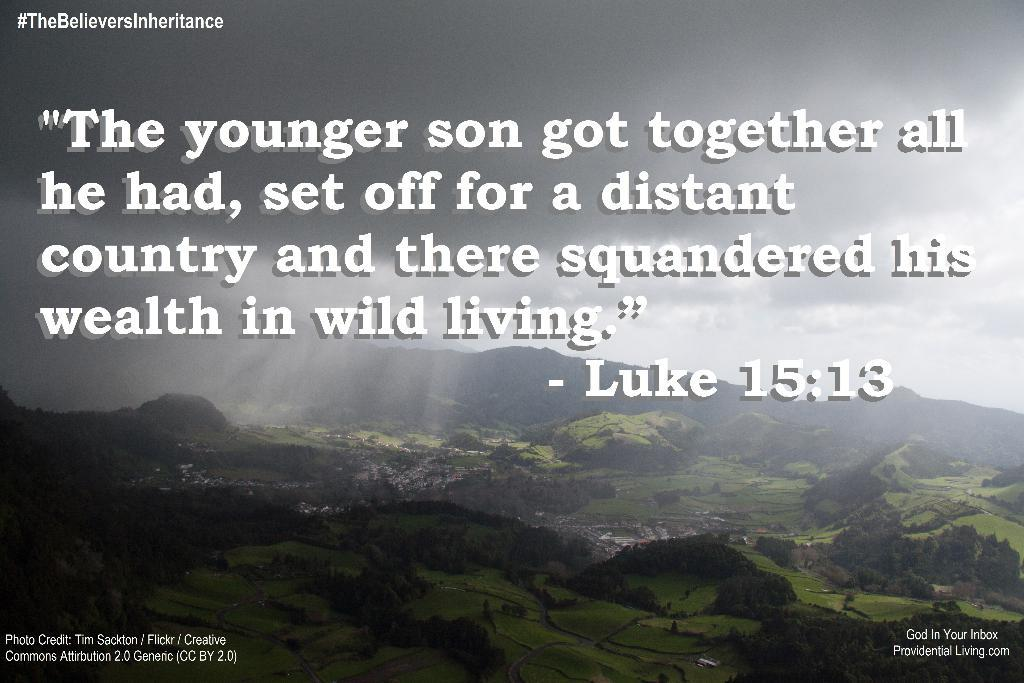What can be found in the image that contains written information? There is text in the image. What type of natural scenery is visible in the background of the image? There are hills, trees, and grass in the background of the image. How would you describe the weather based on the sky in the image? The sky is cloudy in the background of the image, suggesting a potentially overcast or cloudy day. What type of bread is being used to sign the agreement in the image? There is no bread or agreement present in the image; it only contains text, hills, trees, grass, and a cloudy sky. 